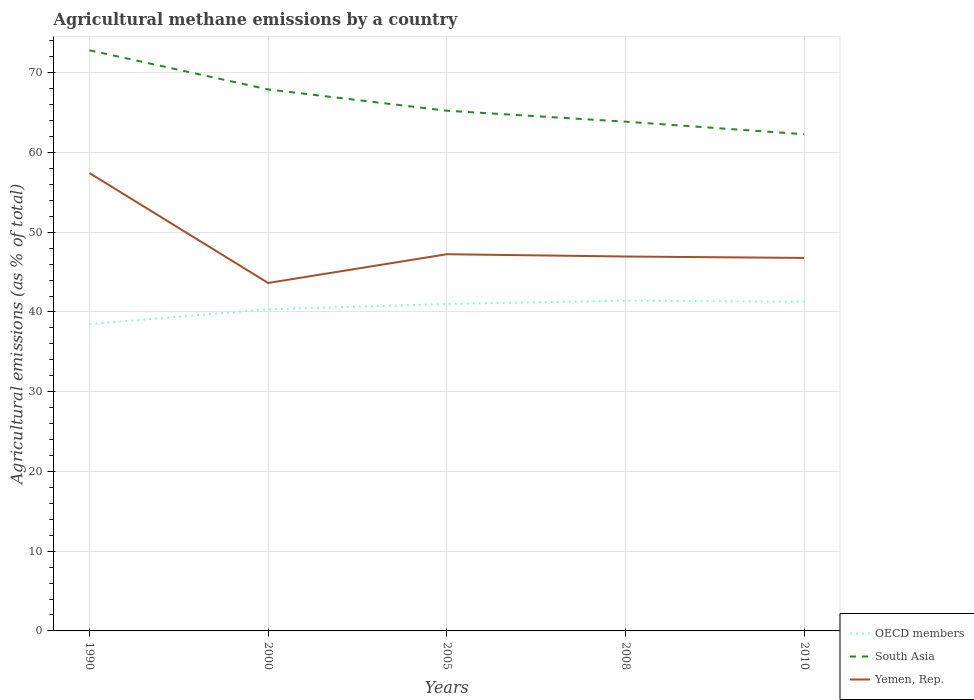Is the number of lines equal to the number of legend labels?
Your answer should be very brief. Yes. Across all years, what is the maximum amount of agricultural methane emitted in Yemen, Rep.?
Make the answer very short. 43.64. In which year was the amount of agricultural methane emitted in South Asia maximum?
Keep it short and to the point. 2010. What is the total amount of agricultural methane emitted in OECD members in the graph?
Give a very brief answer. -2.81. What is the difference between the highest and the second highest amount of agricultural methane emitted in OECD members?
Provide a succinct answer. 2.93. What is the difference between the highest and the lowest amount of agricultural methane emitted in Yemen, Rep.?
Your answer should be very brief. 1. How many lines are there?
Your answer should be compact. 3. Are the values on the major ticks of Y-axis written in scientific E-notation?
Make the answer very short. No. Does the graph contain any zero values?
Provide a succinct answer. No. How many legend labels are there?
Your response must be concise. 3. What is the title of the graph?
Your response must be concise. Agricultural methane emissions by a country. What is the label or title of the X-axis?
Your answer should be very brief. Years. What is the label or title of the Y-axis?
Your response must be concise. Agricultural emissions (as % of total). What is the Agricultural emissions (as % of total) of OECD members in 1990?
Provide a short and direct response. 38.48. What is the Agricultural emissions (as % of total) in South Asia in 1990?
Your answer should be compact. 72.82. What is the Agricultural emissions (as % of total) of Yemen, Rep. in 1990?
Your answer should be compact. 57.42. What is the Agricultural emissions (as % of total) in OECD members in 2000?
Offer a terse response. 40.33. What is the Agricultural emissions (as % of total) in South Asia in 2000?
Offer a very short reply. 67.91. What is the Agricultural emissions (as % of total) in Yemen, Rep. in 2000?
Your response must be concise. 43.64. What is the Agricultural emissions (as % of total) of OECD members in 2005?
Ensure brevity in your answer.  41. What is the Agricultural emissions (as % of total) of South Asia in 2005?
Give a very brief answer. 65.24. What is the Agricultural emissions (as % of total) in Yemen, Rep. in 2005?
Make the answer very short. 47.24. What is the Agricultural emissions (as % of total) in OECD members in 2008?
Your answer should be compact. 41.41. What is the Agricultural emissions (as % of total) of South Asia in 2008?
Offer a terse response. 63.86. What is the Agricultural emissions (as % of total) of Yemen, Rep. in 2008?
Your answer should be very brief. 46.95. What is the Agricultural emissions (as % of total) of OECD members in 2010?
Your response must be concise. 41.29. What is the Agricultural emissions (as % of total) in South Asia in 2010?
Keep it short and to the point. 62.29. What is the Agricultural emissions (as % of total) of Yemen, Rep. in 2010?
Keep it short and to the point. 46.78. Across all years, what is the maximum Agricultural emissions (as % of total) in OECD members?
Give a very brief answer. 41.41. Across all years, what is the maximum Agricultural emissions (as % of total) in South Asia?
Give a very brief answer. 72.82. Across all years, what is the maximum Agricultural emissions (as % of total) in Yemen, Rep.?
Provide a short and direct response. 57.42. Across all years, what is the minimum Agricultural emissions (as % of total) in OECD members?
Ensure brevity in your answer.  38.48. Across all years, what is the minimum Agricultural emissions (as % of total) of South Asia?
Ensure brevity in your answer.  62.29. Across all years, what is the minimum Agricultural emissions (as % of total) of Yemen, Rep.?
Offer a terse response. 43.64. What is the total Agricultural emissions (as % of total) of OECD members in the graph?
Your response must be concise. 202.52. What is the total Agricultural emissions (as % of total) of South Asia in the graph?
Offer a very short reply. 332.11. What is the total Agricultural emissions (as % of total) in Yemen, Rep. in the graph?
Offer a very short reply. 242.03. What is the difference between the Agricultural emissions (as % of total) of OECD members in 1990 and that in 2000?
Provide a short and direct response. -1.86. What is the difference between the Agricultural emissions (as % of total) of South Asia in 1990 and that in 2000?
Provide a succinct answer. 4.91. What is the difference between the Agricultural emissions (as % of total) in Yemen, Rep. in 1990 and that in 2000?
Ensure brevity in your answer.  13.79. What is the difference between the Agricultural emissions (as % of total) in OECD members in 1990 and that in 2005?
Provide a succinct answer. -2.52. What is the difference between the Agricultural emissions (as % of total) of South Asia in 1990 and that in 2005?
Your response must be concise. 7.58. What is the difference between the Agricultural emissions (as % of total) of Yemen, Rep. in 1990 and that in 2005?
Your answer should be very brief. 10.18. What is the difference between the Agricultural emissions (as % of total) of OECD members in 1990 and that in 2008?
Provide a short and direct response. -2.93. What is the difference between the Agricultural emissions (as % of total) of South Asia in 1990 and that in 2008?
Your response must be concise. 8.96. What is the difference between the Agricultural emissions (as % of total) of Yemen, Rep. in 1990 and that in 2008?
Give a very brief answer. 10.47. What is the difference between the Agricultural emissions (as % of total) in OECD members in 1990 and that in 2010?
Offer a very short reply. -2.81. What is the difference between the Agricultural emissions (as % of total) of South Asia in 1990 and that in 2010?
Keep it short and to the point. 10.53. What is the difference between the Agricultural emissions (as % of total) of Yemen, Rep. in 1990 and that in 2010?
Your answer should be compact. 10.64. What is the difference between the Agricultural emissions (as % of total) in OECD members in 2000 and that in 2005?
Make the answer very short. -0.67. What is the difference between the Agricultural emissions (as % of total) of South Asia in 2000 and that in 2005?
Your response must be concise. 2.67. What is the difference between the Agricultural emissions (as % of total) of Yemen, Rep. in 2000 and that in 2005?
Your answer should be compact. -3.61. What is the difference between the Agricultural emissions (as % of total) in OECD members in 2000 and that in 2008?
Offer a terse response. -1.08. What is the difference between the Agricultural emissions (as % of total) of South Asia in 2000 and that in 2008?
Your answer should be very brief. 4.04. What is the difference between the Agricultural emissions (as % of total) of Yemen, Rep. in 2000 and that in 2008?
Keep it short and to the point. -3.32. What is the difference between the Agricultural emissions (as % of total) of OECD members in 2000 and that in 2010?
Keep it short and to the point. -0.96. What is the difference between the Agricultural emissions (as % of total) of South Asia in 2000 and that in 2010?
Ensure brevity in your answer.  5.62. What is the difference between the Agricultural emissions (as % of total) in Yemen, Rep. in 2000 and that in 2010?
Provide a short and direct response. -3.14. What is the difference between the Agricultural emissions (as % of total) in OECD members in 2005 and that in 2008?
Offer a very short reply. -0.41. What is the difference between the Agricultural emissions (as % of total) of South Asia in 2005 and that in 2008?
Your answer should be very brief. 1.37. What is the difference between the Agricultural emissions (as % of total) of Yemen, Rep. in 2005 and that in 2008?
Keep it short and to the point. 0.29. What is the difference between the Agricultural emissions (as % of total) of OECD members in 2005 and that in 2010?
Ensure brevity in your answer.  -0.29. What is the difference between the Agricultural emissions (as % of total) in South Asia in 2005 and that in 2010?
Keep it short and to the point. 2.95. What is the difference between the Agricultural emissions (as % of total) in Yemen, Rep. in 2005 and that in 2010?
Offer a very short reply. 0.46. What is the difference between the Agricultural emissions (as % of total) of OECD members in 2008 and that in 2010?
Give a very brief answer. 0.12. What is the difference between the Agricultural emissions (as % of total) in South Asia in 2008 and that in 2010?
Offer a terse response. 1.58. What is the difference between the Agricultural emissions (as % of total) of Yemen, Rep. in 2008 and that in 2010?
Offer a terse response. 0.18. What is the difference between the Agricultural emissions (as % of total) of OECD members in 1990 and the Agricultural emissions (as % of total) of South Asia in 2000?
Make the answer very short. -29.43. What is the difference between the Agricultural emissions (as % of total) of OECD members in 1990 and the Agricultural emissions (as % of total) of Yemen, Rep. in 2000?
Keep it short and to the point. -5.16. What is the difference between the Agricultural emissions (as % of total) in South Asia in 1990 and the Agricultural emissions (as % of total) in Yemen, Rep. in 2000?
Ensure brevity in your answer.  29.18. What is the difference between the Agricultural emissions (as % of total) of OECD members in 1990 and the Agricultural emissions (as % of total) of South Asia in 2005?
Give a very brief answer. -26.76. What is the difference between the Agricultural emissions (as % of total) in OECD members in 1990 and the Agricultural emissions (as % of total) in Yemen, Rep. in 2005?
Provide a succinct answer. -8.76. What is the difference between the Agricultural emissions (as % of total) of South Asia in 1990 and the Agricultural emissions (as % of total) of Yemen, Rep. in 2005?
Your response must be concise. 25.58. What is the difference between the Agricultural emissions (as % of total) in OECD members in 1990 and the Agricultural emissions (as % of total) in South Asia in 2008?
Your response must be concise. -25.38. What is the difference between the Agricultural emissions (as % of total) in OECD members in 1990 and the Agricultural emissions (as % of total) in Yemen, Rep. in 2008?
Make the answer very short. -8.48. What is the difference between the Agricultural emissions (as % of total) in South Asia in 1990 and the Agricultural emissions (as % of total) in Yemen, Rep. in 2008?
Make the answer very short. 25.86. What is the difference between the Agricultural emissions (as % of total) in OECD members in 1990 and the Agricultural emissions (as % of total) in South Asia in 2010?
Make the answer very short. -23.81. What is the difference between the Agricultural emissions (as % of total) of OECD members in 1990 and the Agricultural emissions (as % of total) of Yemen, Rep. in 2010?
Ensure brevity in your answer.  -8.3. What is the difference between the Agricultural emissions (as % of total) of South Asia in 1990 and the Agricultural emissions (as % of total) of Yemen, Rep. in 2010?
Keep it short and to the point. 26.04. What is the difference between the Agricultural emissions (as % of total) of OECD members in 2000 and the Agricultural emissions (as % of total) of South Asia in 2005?
Your answer should be compact. -24.9. What is the difference between the Agricultural emissions (as % of total) in OECD members in 2000 and the Agricultural emissions (as % of total) in Yemen, Rep. in 2005?
Your answer should be compact. -6.91. What is the difference between the Agricultural emissions (as % of total) of South Asia in 2000 and the Agricultural emissions (as % of total) of Yemen, Rep. in 2005?
Your response must be concise. 20.67. What is the difference between the Agricultural emissions (as % of total) of OECD members in 2000 and the Agricultural emissions (as % of total) of South Asia in 2008?
Your answer should be very brief. -23.53. What is the difference between the Agricultural emissions (as % of total) in OECD members in 2000 and the Agricultural emissions (as % of total) in Yemen, Rep. in 2008?
Your response must be concise. -6.62. What is the difference between the Agricultural emissions (as % of total) of South Asia in 2000 and the Agricultural emissions (as % of total) of Yemen, Rep. in 2008?
Offer a terse response. 20.95. What is the difference between the Agricultural emissions (as % of total) in OECD members in 2000 and the Agricultural emissions (as % of total) in South Asia in 2010?
Give a very brief answer. -21.95. What is the difference between the Agricultural emissions (as % of total) in OECD members in 2000 and the Agricultural emissions (as % of total) in Yemen, Rep. in 2010?
Make the answer very short. -6.44. What is the difference between the Agricultural emissions (as % of total) of South Asia in 2000 and the Agricultural emissions (as % of total) of Yemen, Rep. in 2010?
Your answer should be very brief. 21.13. What is the difference between the Agricultural emissions (as % of total) in OECD members in 2005 and the Agricultural emissions (as % of total) in South Asia in 2008?
Make the answer very short. -22.86. What is the difference between the Agricultural emissions (as % of total) in OECD members in 2005 and the Agricultural emissions (as % of total) in Yemen, Rep. in 2008?
Ensure brevity in your answer.  -5.95. What is the difference between the Agricultural emissions (as % of total) in South Asia in 2005 and the Agricultural emissions (as % of total) in Yemen, Rep. in 2008?
Give a very brief answer. 18.28. What is the difference between the Agricultural emissions (as % of total) in OECD members in 2005 and the Agricultural emissions (as % of total) in South Asia in 2010?
Provide a succinct answer. -21.28. What is the difference between the Agricultural emissions (as % of total) of OECD members in 2005 and the Agricultural emissions (as % of total) of Yemen, Rep. in 2010?
Your answer should be very brief. -5.77. What is the difference between the Agricultural emissions (as % of total) in South Asia in 2005 and the Agricultural emissions (as % of total) in Yemen, Rep. in 2010?
Give a very brief answer. 18.46. What is the difference between the Agricultural emissions (as % of total) in OECD members in 2008 and the Agricultural emissions (as % of total) in South Asia in 2010?
Provide a succinct answer. -20.87. What is the difference between the Agricultural emissions (as % of total) in OECD members in 2008 and the Agricultural emissions (as % of total) in Yemen, Rep. in 2010?
Provide a succinct answer. -5.36. What is the difference between the Agricultural emissions (as % of total) of South Asia in 2008 and the Agricultural emissions (as % of total) of Yemen, Rep. in 2010?
Your answer should be compact. 17.09. What is the average Agricultural emissions (as % of total) of OECD members per year?
Give a very brief answer. 40.5. What is the average Agricultural emissions (as % of total) in South Asia per year?
Make the answer very short. 66.42. What is the average Agricultural emissions (as % of total) of Yemen, Rep. per year?
Provide a succinct answer. 48.41. In the year 1990, what is the difference between the Agricultural emissions (as % of total) in OECD members and Agricultural emissions (as % of total) in South Asia?
Provide a succinct answer. -34.34. In the year 1990, what is the difference between the Agricultural emissions (as % of total) in OECD members and Agricultural emissions (as % of total) in Yemen, Rep.?
Keep it short and to the point. -18.94. In the year 1990, what is the difference between the Agricultural emissions (as % of total) in South Asia and Agricultural emissions (as % of total) in Yemen, Rep.?
Your answer should be very brief. 15.4. In the year 2000, what is the difference between the Agricultural emissions (as % of total) of OECD members and Agricultural emissions (as % of total) of South Asia?
Provide a short and direct response. -27.57. In the year 2000, what is the difference between the Agricultural emissions (as % of total) in OECD members and Agricultural emissions (as % of total) in Yemen, Rep.?
Give a very brief answer. -3.3. In the year 2000, what is the difference between the Agricultural emissions (as % of total) of South Asia and Agricultural emissions (as % of total) of Yemen, Rep.?
Your answer should be very brief. 24.27. In the year 2005, what is the difference between the Agricultural emissions (as % of total) in OECD members and Agricultural emissions (as % of total) in South Asia?
Your response must be concise. -24.23. In the year 2005, what is the difference between the Agricultural emissions (as % of total) of OECD members and Agricultural emissions (as % of total) of Yemen, Rep.?
Ensure brevity in your answer.  -6.24. In the year 2005, what is the difference between the Agricultural emissions (as % of total) in South Asia and Agricultural emissions (as % of total) in Yemen, Rep.?
Make the answer very short. 17.99. In the year 2008, what is the difference between the Agricultural emissions (as % of total) in OECD members and Agricultural emissions (as % of total) in South Asia?
Give a very brief answer. -22.45. In the year 2008, what is the difference between the Agricultural emissions (as % of total) in OECD members and Agricultural emissions (as % of total) in Yemen, Rep.?
Provide a succinct answer. -5.54. In the year 2008, what is the difference between the Agricultural emissions (as % of total) in South Asia and Agricultural emissions (as % of total) in Yemen, Rep.?
Ensure brevity in your answer.  16.91. In the year 2010, what is the difference between the Agricultural emissions (as % of total) of OECD members and Agricultural emissions (as % of total) of South Asia?
Your answer should be very brief. -21. In the year 2010, what is the difference between the Agricultural emissions (as % of total) in OECD members and Agricultural emissions (as % of total) in Yemen, Rep.?
Offer a terse response. -5.49. In the year 2010, what is the difference between the Agricultural emissions (as % of total) in South Asia and Agricultural emissions (as % of total) in Yemen, Rep.?
Offer a terse response. 15.51. What is the ratio of the Agricultural emissions (as % of total) of OECD members in 1990 to that in 2000?
Your answer should be very brief. 0.95. What is the ratio of the Agricultural emissions (as % of total) in South Asia in 1990 to that in 2000?
Ensure brevity in your answer.  1.07. What is the ratio of the Agricultural emissions (as % of total) of Yemen, Rep. in 1990 to that in 2000?
Offer a very short reply. 1.32. What is the ratio of the Agricultural emissions (as % of total) of OECD members in 1990 to that in 2005?
Your answer should be compact. 0.94. What is the ratio of the Agricultural emissions (as % of total) of South Asia in 1990 to that in 2005?
Your answer should be very brief. 1.12. What is the ratio of the Agricultural emissions (as % of total) in Yemen, Rep. in 1990 to that in 2005?
Ensure brevity in your answer.  1.22. What is the ratio of the Agricultural emissions (as % of total) of OECD members in 1990 to that in 2008?
Provide a succinct answer. 0.93. What is the ratio of the Agricultural emissions (as % of total) in South Asia in 1990 to that in 2008?
Offer a very short reply. 1.14. What is the ratio of the Agricultural emissions (as % of total) in Yemen, Rep. in 1990 to that in 2008?
Provide a succinct answer. 1.22. What is the ratio of the Agricultural emissions (as % of total) of OECD members in 1990 to that in 2010?
Offer a terse response. 0.93. What is the ratio of the Agricultural emissions (as % of total) of South Asia in 1990 to that in 2010?
Provide a short and direct response. 1.17. What is the ratio of the Agricultural emissions (as % of total) in Yemen, Rep. in 1990 to that in 2010?
Provide a short and direct response. 1.23. What is the ratio of the Agricultural emissions (as % of total) of OECD members in 2000 to that in 2005?
Keep it short and to the point. 0.98. What is the ratio of the Agricultural emissions (as % of total) in South Asia in 2000 to that in 2005?
Ensure brevity in your answer.  1.04. What is the ratio of the Agricultural emissions (as % of total) of Yemen, Rep. in 2000 to that in 2005?
Your answer should be very brief. 0.92. What is the ratio of the Agricultural emissions (as % of total) in OECD members in 2000 to that in 2008?
Give a very brief answer. 0.97. What is the ratio of the Agricultural emissions (as % of total) in South Asia in 2000 to that in 2008?
Your response must be concise. 1.06. What is the ratio of the Agricultural emissions (as % of total) of Yemen, Rep. in 2000 to that in 2008?
Your response must be concise. 0.93. What is the ratio of the Agricultural emissions (as % of total) of OECD members in 2000 to that in 2010?
Make the answer very short. 0.98. What is the ratio of the Agricultural emissions (as % of total) of South Asia in 2000 to that in 2010?
Make the answer very short. 1.09. What is the ratio of the Agricultural emissions (as % of total) of Yemen, Rep. in 2000 to that in 2010?
Your answer should be very brief. 0.93. What is the ratio of the Agricultural emissions (as % of total) of OECD members in 2005 to that in 2008?
Provide a succinct answer. 0.99. What is the ratio of the Agricultural emissions (as % of total) in South Asia in 2005 to that in 2008?
Ensure brevity in your answer.  1.02. What is the ratio of the Agricultural emissions (as % of total) of Yemen, Rep. in 2005 to that in 2008?
Ensure brevity in your answer.  1.01. What is the ratio of the Agricultural emissions (as % of total) in OECD members in 2005 to that in 2010?
Give a very brief answer. 0.99. What is the ratio of the Agricultural emissions (as % of total) in South Asia in 2005 to that in 2010?
Give a very brief answer. 1.05. What is the ratio of the Agricultural emissions (as % of total) in Yemen, Rep. in 2005 to that in 2010?
Provide a short and direct response. 1.01. What is the ratio of the Agricultural emissions (as % of total) in South Asia in 2008 to that in 2010?
Give a very brief answer. 1.03. What is the ratio of the Agricultural emissions (as % of total) of Yemen, Rep. in 2008 to that in 2010?
Ensure brevity in your answer.  1. What is the difference between the highest and the second highest Agricultural emissions (as % of total) in OECD members?
Provide a short and direct response. 0.12. What is the difference between the highest and the second highest Agricultural emissions (as % of total) of South Asia?
Offer a very short reply. 4.91. What is the difference between the highest and the second highest Agricultural emissions (as % of total) in Yemen, Rep.?
Provide a succinct answer. 10.18. What is the difference between the highest and the lowest Agricultural emissions (as % of total) of OECD members?
Ensure brevity in your answer.  2.93. What is the difference between the highest and the lowest Agricultural emissions (as % of total) of South Asia?
Offer a very short reply. 10.53. What is the difference between the highest and the lowest Agricultural emissions (as % of total) in Yemen, Rep.?
Your answer should be very brief. 13.79. 